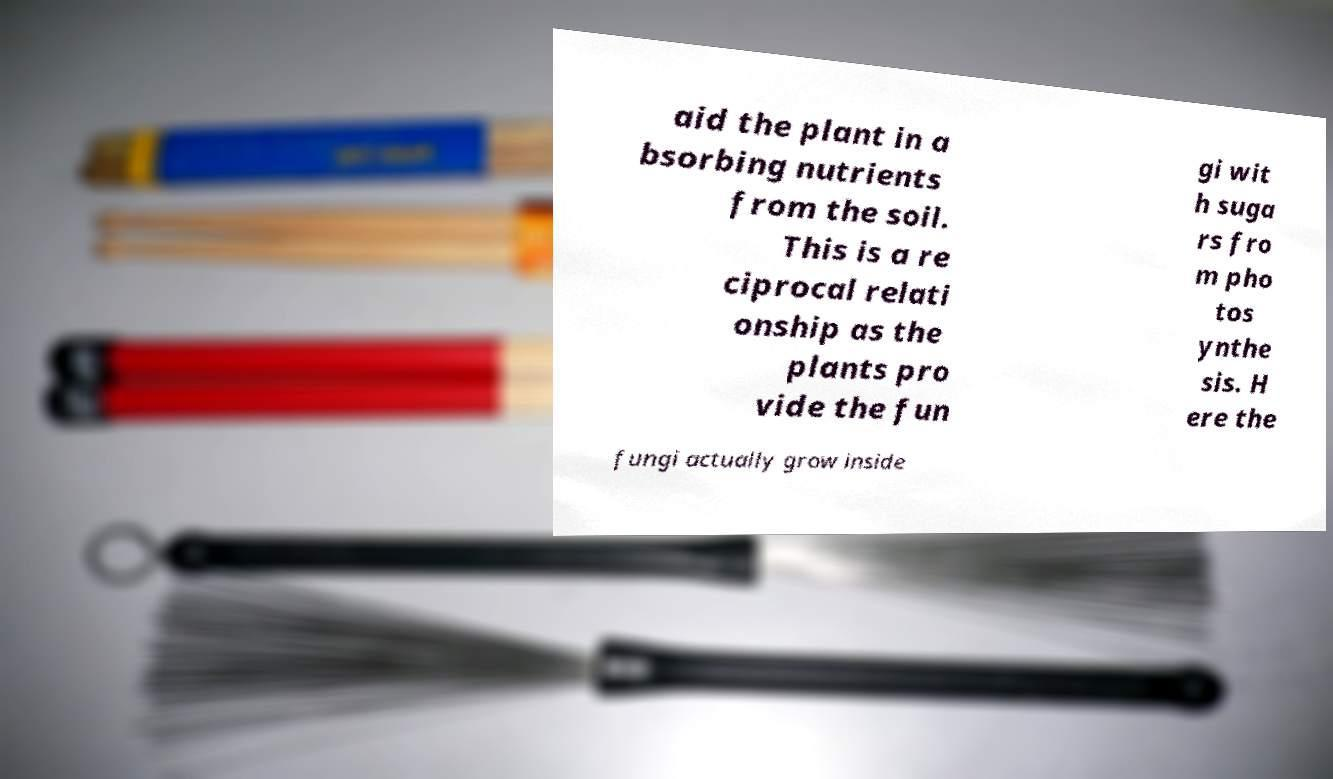Please read and relay the text visible in this image. What does it say? aid the plant in a bsorbing nutrients from the soil. This is a re ciprocal relati onship as the plants pro vide the fun gi wit h suga rs fro m pho tos ynthe sis. H ere the fungi actually grow inside 